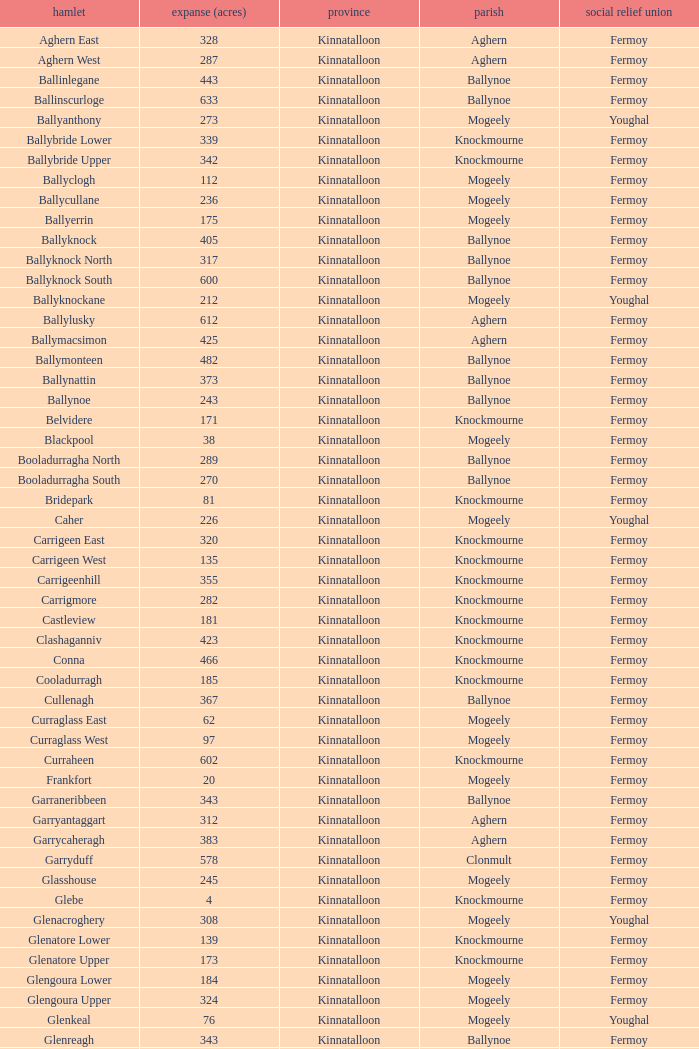Name the area for civil parish ballynoe and killasseragh 340.0. 